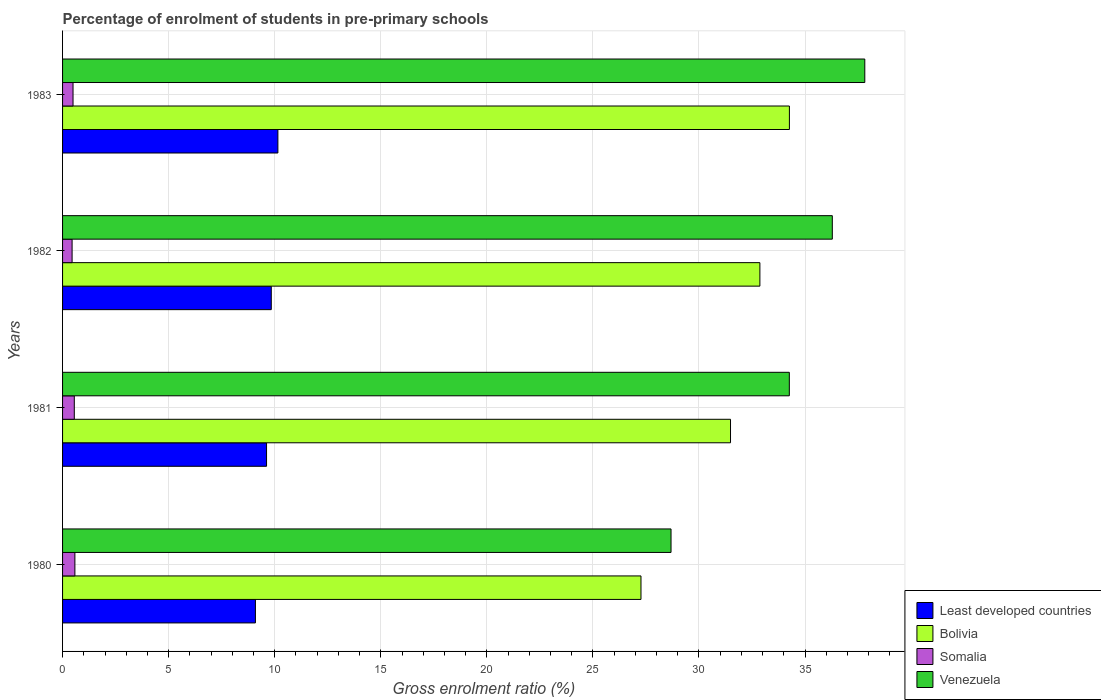How many different coloured bars are there?
Keep it short and to the point. 4. Are the number of bars on each tick of the Y-axis equal?
Give a very brief answer. Yes. How many bars are there on the 2nd tick from the top?
Your response must be concise. 4. How many bars are there on the 2nd tick from the bottom?
Provide a succinct answer. 4. What is the percentage of students enrolled in pre-primary schools in Venezuela in 1983?
Offer a terse response. 37.82. Across all years, what is the maximum percentage of students enrolled in pre-primary schools in Somalia?
Provide a succinct answer. 0.58. Across all years, what is the minimum percentage of students enrolled in pre-primary schools in Least developed countries?
Provide a succinct answer. 9.09. What is the total percentage of students enrolled in pre-primary schools in Bolivia in the graph?
Provide a short and direct response. 125.89. What is the difference between the percentage of students enrolled in pre-primary schools in Least developed countries in 1980 and that in 1981?
Keep it short and to the point. -0.52. What is the difference between the percentage of students enrolled in pre-primary schools in Least developed countries in 1981 and the percentage of students enrolled in pre-primary schools in Venezuela in 1982?
Offer a terse response. -26.67. What is the average percentage of students enrolled in pre-primary schools in Least developed countries per year?
Offer a very short reply. 9.67. In the year 1983, what is the difference between the percentage of students enrolled in pre-primary schools in Least developed countries and percentage of students enrolled in pre-primary schools in Bolivia?
Offer a terse response. -24.11. What is the ratio of the percentage of students enrolled in pre-primary schools in Bolivia in 1980 to that in 1983?
Offer a terse response. 0.8. Is the difference between the percentage of students enrolled in pre-primary schools in Least developed countries in 1980 and 1981 greater than the difference between the percentage of students enrolled in pre-primary schools in Bolivia in 1980 and 1981?
Keep it short and to the point. Yes. What is the difference between the highest and the second highest percentage of students enrolled in pre-primary schools in Least developed countries?
Provide a succinct answer. 0.31. What is the difference between the highest and the lowest percentage of students enrolled in pre-primary schools in Bolivia?
Your response must be concise. 7. Is it the case that in every year, the sum of the percentage of students enrolled in pre-primary schools in Somalia and percentage of students enrolled in pre-primary schools in Bolivia is greater than the sum of percentage of students enrolled in pre-primary schools in Venezuela and percentage of students enrolled in pre-primary schools in Least developed countries?
Provide a succinct answer. No. How many bars are there?
Give a very brief answer. 16. What is the difference between two consecutive major ticks on the X-axis?
Your answer should be compact. 5. Are the values on the major ticks of X-axis written in scientific E-notation?
Ensure brevity in your answer.  No. Does the graph contain any zero values?
Offer a terse response. No. Does the graph contain grids?
Your answer should be very brief. Yes. Where does the legend appear in the graph?
Provide a succinct answer. Bottom right. How are the legend labels stacked?
Keep it short and to the point. Vertical. What is the title of the graph?
Give a very brief answer. Percentage of enrolment of students in pre-primary schools. Does "Palau" appear as one of the legend labels in the graph?
Your answer should be compact. No. What is the label or title of the X-axis?
Offer a terse response. Gross enrolment ratio (%). What is the Gross enrolment ratio (%) in Least developed countries in 1980?
Offer a very short reply. 9.09. What is the Gross enrolment ratio (%) in Bolivia in 1980?
Offer a terse response. 27.27. What is the Gross enrolment ratio (%) of Somalia in 1980?
Your answer should be compact. 0.58. What is the Gross enrolment ratio (%) in Venezuela in 1980?
Keep it short and to the point. 28.68. What is the Gross enrolment ratio (%) of Least developed countries in 1981?
Your answer should be compact. 9.62. What is the Gross enrolment ratio (%) of Bolivia in 1981?
Your answer should be compact. 31.49. What is the Gross enrolment ratio (%) in Somalia in 1981?
Your answer should be compact. 0.55. What is the Gross enrolment ratio (%) of Venezuela in 1981?
Your answer should be compact. 34.26. What is the Gross enrolment ratio (%) of Least developed countries in 1982?
Offer a terse response. 9.84. What is the Gross enrolment ratio (%) in Bolivia in 1982?
Ensure brevity in your answer.  32.87. What is the Gross enrolment ratio (%) in Somalia in 1982?
Your answer should be compact. 0.45. What is the Gross enrolment ratio (%) in Venezuela in 1982?
Provide a succinct answer. 36.28. What is the Gross enrolment ratio (%) in Least developed countries in 1983?
Offer a very short reply. 10.15. What is the Gross enrolment ratio (%) in Bolivia in 1983?
Your answer should be very brief. 34.26. What is the Gross enrolment ratio (%) in Somalia in 1983?
Your answer should be very brief. 0.49. What is the Gross enrolment ratio (%) of Venezuela in 1983?
Your answer should be compact. 37.82. Across all years, what is the maximum Gross enrolment ratio (%) in Least developed countries?
Ensure brevity in your answer.  10.15. Across all years, what is the maximum Gross enrolment ratio (%) in Bolivia?
Ensure brevity in your answer.  34.26. Across all years, what is the maximum Gross enrolment ratio (%) of Somalia?
Your response must be concise. 0.58. Across all years, what is the maximum Gross enrolment ratio (%) in Venezuela?
Offer a terse response. 37.82. Across all years, what is the minimum Gross enrolment ratio (%) in Least developed countries?
Your answer should be very brief. 9.09. Across all years, what is the minimum Gross enrolment ratio (%) of Bolivia?
Provide a succinct answer. 27.27. Across all years, what is the minimum Gross enrolment ratio (%) in Somalia?
Provide a short and direct response. 0.45. Across all years, what is the minimum Gross enrolment ratio (%) in Venezuela?
Your response must be concise. 28.68. What is the total Gross enrolment ratio (%) of Least developed countries in the graph?
Offer a very short reply. 38.69. What is the total Gross enrolment ratio (%) of Bolivia in the graph?
Your answer should be compact. 125.89. What is the total Gross enrolment ratio (%) of Somalia in the graph?
Your answer should be compact. 2.08. What is the total Gross enrolment ratio (%) in Venezuela in the graph?
Your answer should be very brief. 137.04. What is the difference between the Gross enrolment ratio (%) in Least developed countries in 1980 and that in 1981?
Offer a very short reply. -0.52. What is the difference between the Gross enrolment ratio (%) of Bolivia in 1980 and that in 1981?
Make the answer very short. -4.22. What is the difference between the Gross enrolment ratio (%) in Somalia in 1980 and that in 1981?
Ensure brevity in your answer.  0.03. What is the difference between the Gross enrolment ratio (%) of Venezuela in 1980 and that in 1981?
Provide a short and direct response. -5.58. What is the difference between the Gross enrolment ratio (%) in Least developed countries in 1980 and that in 1982?
Offer a very short reply. -0.75. What is the difference between the Gross enrolment ratio (%) in Bolivia in 1980 and that in 1982?
Your answer should be very brief. -5.61. What is the difference between the Gross enrolment ratio (%) in Somalia in 1980 and that in 1982?
Provide a short and direct response. 0.13. What is the difference between the Gross enrolment ratio (%) of Venezuela in 1980 and that in 1982?
Offer a very short reply. -7.6. What is the difference between the Gross enrolment ratio (%) in Least developed countries in 1980 and that in 1983?
Keep it short and to the point. -1.06. What is the difference between the Gross enrolment ratio (%) of Bolivia in 1980 and that in 1983?
Keep it short and to the point. -7. What is the difference between the Gross enrolment ratio (%) in Somalia in 1980 and that in 1983?
Your answer should be compact. 0.09. What is the difference between the Gross enrolment ratio (%) of Venezuela in 1980 and that in 1983?
Provide a succinct answer. -9.13. What is the difference between the Gross enrolment ratio (%) of Least developed countries in 1981 and that in 1982?
Keep it short and to the point. -0.22. What is the difference between the Gross enrolment ratio (%) in Bolivia in 1981 and that in 1982?
Offer a terse response. -1.38. What is the difference between the Gross enrolment ratio (%) in Somalia in 1981 and that in 1982?
Keep it short and to the point. 0.1. What is the difference between the Gross enrolment ratio (%) of Venezuela in 1981 and that in 1982?
Provide a short and direct response. -2.03. What is the difference between the Gross enrolment ratio (%) in Least developed countries in 1981 and that in 1983?
Ensure brevity in your answer.  -0.53. What is the difference between the Gross enrolment ratio (%) in Bolivia in 1981 and that in 1983?
Provide a short and direct response. -2.78. What is the difference between the Gross enrolment ratio (%) in Somalia in 1981 and that in 1983?
Give a very brief answer. 0.06. What is the difference between the Gross enrolment ratio (%) of Venezuela in 1981 and that in 1983?
Your response must be concise. -3.56. What is the difference between the Gross enrolment ratio (%) of Least developed countries in 1982 and that in 1983?
Offer a very short reply. -0.31. What is the difference between the Gross enrolment ratio (%) of Bolivia in 1982 and that in 1983?
Make the answer very short. -1.39. What is the difference between the Gross enrolment ratio (%) in Somalia in 1982 and that in 1983?
Offer a terse response. -0.04. What is the difference between the Gross enrolment ratio (%) in Venezuela in 1982 and that in 1983?
Give a very brief answer. -1.53. What is the difference between the Gross enrolment ratio (%) of Least developed countries in 1980 and the Gross enrolment ratio (%) of Bolivia in 1981?
Provide a succinct answer. -22.4. What is the difference between the Gross enrolment ratio (%) of Least developed countries in 1980 and the Gross enrolment ratio (%) of Somalia in 1981?
Provide a succinct answer. 8.54. What is the difference between the Gross enrolment ratio (%) in Least developed countries in 1980 and the Gross enrolment ratio (%) in Venezuela in 1981?
Offer a terse response. -25.17. What is the difference between the Gross enrolment ratio (%) in Bolivia in 1980 and the Gross enrolment ratio (%) in Somalia in 1981?
Ensure brevity in your answer.  26.71. What is the difference between the Gross enrolment ratio (%) of Bolivia in 1980 and the Gross enrolment ratio (%) of Venezuela in 1981?
Give a very brief answer. -6.99. What is the difference between the Gross enrolment ratio (%) in Somalia in 1980 and the Gross enrolment ratio (%) in Venezuela in 1981?
Offer a terse response. -33.68. What is the difference between the Gross enrolment ratio (%) of Least developed countries in 1980 and the Gross enrolment ratio (%) of Bolivia in 1982?
Offer a terse response. -23.78. What is the difference between the Gross enrolment ratio (%) in Least developed countries in 1980 and the Gross enrolment ratio (%) in Somalia in 1982?
Your answer should be very brief. 8.64. What is the difference between the Gross enrolment ratio (%) of Least developed countries in 1980 and the Gross enrolment ratio (%) of Venezuela in 1982?
Your response must be concise. -27.19. What is the difference between the Gross enrolment ratio (%) of Bolivia in 1980 and the Gross enrolment ratio (%) of Somalia in 1982?
Your answer should be compact. 26.82. What is the difference between the Gross enrolment ratio (%) of Bolivia in 1980 and the Gross enrolment ratio (%) of Venezuela in 1982?
Your response must be concise. -9.02. What is the difference between the Gross enrolment ratio (%) of Somalia in 1980 and the Gross enrolment ratio (%) of Venezuela in 1982?
Ensure brevity in your answer.  -35.7. What is the difference between the Gross enrolment ratio (%) in Least developed countries in 1980 and the Gross enrolment ratio (%) in Bolivia in 1983?
Provide a short and direct response. -25.17. What is the difference between the Gross enrolment ratio (%) in Least developed countries in 1980 and the Gross enrolment ratio (%) in Somalia in 1983?
Your response must be concise. 8.6. What is the difference between the Gross enrolment ratio (%) in Least developed countries in 1980 and the Gross enrolment ratio (%) in Venezuela in 1983?
Your response must be concise. -28.73. What is the difference between the Gross enrolment ratio (%) of Bolivia in 1980 and the Gross enrolment ratio (%) of Somalia in 1983?
Your response must be concise. 26.77. What is the difference between the Gross enrolment ratio (%) of Bolivia in 1980 and the Gross enrolment ratio (%) of Venezuela in 1983?
Ensure brevity in your answer.  -10.55. What is the difference between the Gross enrolment ratio (%) in Somalia in 1980 and the Gross enrolment ratio (%) in Venezuela in 1983?
Make the answer very short. -37.23. What is the difference between the Gross enrolment ratio (%) in Least developed countries in 1981 and the Gross enrolment ratio (%) in Bolivia in 1982?
Offer a terse response. -23.26. What is the difference between the Gross enrolment ratio (%) in Least developed countries in 1981 and the Gross enrolment ratio (%) in Somalia in 1982?
Provide a succinct answer. 9.17. What is the difference between the Gross enrolment ratio (%) of Least developed countries in 1981 and the Gross enrolment ratio (%) of Venezuela in 1982?
Your answer should be compact. -26.67. What is the difference between the Gross enrolment ratio (%) in Bolivia in 1981 and the Gross enrolment ratio (%) in Somalia in 1982?
Offer a very short reply. 31.04. What is the difference between the Gross enrolment ratio (%) in Bolivia in 1981 and the Gross enrolment ratio (%) in Venezuela in 1982?
Give a very brief answer. -4.8. What is the difference between the Gross enrolment ratio (%) of Somalia in 1981 and the Gross enrolment ratio (%) of Venezuela in 1982?
Make the answer very short. -35.73. What is the difference between the Gross enrolment ratio (%) in Least developed countries in 1981 and the Gross enrolment ratio (%) in Bolivia in 1983?
Keep it short and to the point. -24.65. What is the difference between the Gross enrolment ratio (%) in Least developed countries in 1981 and the Gross enrolment ratio (%) in Somalia in 1983?
Give a very brief answer. 9.12. What is the difference between the Gross enrolment ratio (%) in Least developed countries in 1981 and the Gross enrolment ratio (%) in Venezuela in 1983?
Ensure brevity in your answer.  -28.2. What is the difference between the Gross enrolment ratio (%) in Bolivia in 1981 and the Gross enrolment ratio (%) in Somalia in 1983?
Keep it short and to the point. 30.99. What is the difference between the Gross enrolment ratio (%) of Bolivia in 1981 and the Gross enrolment ratio (%) of Venezuela in 1983?
Offer a very short reply. -6.33. What is the difference between the Gross enrolment ratio (%) of Somalia in 1981 and the Gross enrolment ratio (%) of Venezuela in 1983?
Keep it short and to the point. -37.26. What is the difference between the Gross enrolment ratio (%) of Least developed countries in 1982 and the Gross enrolment ratio (%) of Bolivia in 1983?
Give a very brief answer. -24.42. What is the difference between the Gross enrolment ratio (%) in Least developed countries in 1982 and the Gross enrolment ratio (%) in Somalia in 1983?
Your response must be concise. 9.35. What is the difference between the Gross enrolment ratio (%) of Least developed countries in 1982 and the Gross enrolment ratio (%) of Venezuela in 1983?
Keep it short and to the point. -27.98. What is the difference between the Gross enrolment ratio (%) of Bolivia in 1982 and the Gross enrolment ratio (%) of Somalia in 1983?
Offer a very short reply. 32.38. What is the difference between the Gross enrolment ratio (%) of Bolivia in 1982 and the Gross enrolment ratio (%) of Venezuela in 1983?
Ensure brevity in your answer.  -4.95. What is the difference between the Gross enrolment ratio (%) in Somalia in 1982 and the Gross enrolment ratio (%) in Venezuela in 1983?
Your response must be concise. -37.37. What is the average Gross enrolment ratio (%) of Least developed countries per year?
Provide a short and direct response. 9.67. What is the average Gross enrolment ratio (%) of Bolivia per year?
Ensure brevity in your answer.  31.47. What is the average Gross enrolment ratio (%) in Somalia per year?
Provide a short and direct response. 0.52. What is the average Gross enrolment ratio (%) of Venezuela per year?
Your answer should be very brief. 34.26. In the year 1980, what is the difference between the Gross enrolment ratio (%) in Least developed countries and Gross enrolment ratio (%) in Bolivia?
Your answer should be very brief. -18.18. In the year 1980, what is the difference between the Gross enrolment ratio (%) of Least developed countries and Gross enrolment ratio (%) of Somalia?
Make the answer very short. 8.51. In the year 1980, what is the difference between the Gross enrolment ratio (%) of Least developed countries and Gross enrolment ratio (%) of Venezuela?
Give a very brief answer. -19.59. In the year 1980, what is the difference between the Gross enrolment ratio (%) in Bolivia and Gross enrolment ratio (%) in Somalia?
Offer a very short reply. 26.68. In the year 1980, what is the difference between the Gross enrolment ratio (%) in Bolivia and Gross enrolment ratio (%) in Venezuela?
Your answer should be compact. -1.42. In the year 1980, what is the difference between the Gross enrolment ratio (%) in Somalia and Gross enrolment ratio (%) in Venezuela?
Give a very brief answer. -28.1. In the year 1981, what is the difference between the Gross enrolment ratio (%) in Least developed countries and Gross enrolment ratio (%) in Bolivia?
Your answer should be very brief. -21.87. In the year 1981, what is the difference between the Gross enrolment ratio (%) of Least developed countries and Gross enrolment ratio (%) of Somalia?
Make the answer very short. 9.06. In the year 1981, what is the difference between the Gross enrolment ratio (%) in Least developed countries and Gross enrolment ratio (%) in Venezuela?
Ensure brevity in your answer.  -24.64. In the year 1981, what is the difference between the Gross enrolment ratio (%) in Bolivia and Gross enrolment ratio (%) in Somalia?
Your answer should be very brief. 30.93. In the year 1981, what is the difference between the Gross enrolment ratio (%) of Bolivia and Gross enrolment ratio (%) of Venezuela?
Ensure brevity in your answer.  -2.77. In the year 1981, what is the difference between the Gross enrolment ratio (%) in Somalia and Gross enrolment ratio (%) in Venezuela?
Your answer should be very brief. -33.71. In the year 1982, what is the difference between the Gross enrolment ratio (%) of Least developed countries and Gross enrolment ratio (%) of Bolivia?
Provide a short and direct response. -23.03. In the year 1982, what is the difference between the Gross enrolment ratio (%) in Least developed countries and Gross enrolment ratio (%) in Somalia?
Your response must be concise. 9.39. In the year 1982, what is the difference between the Gross enrolment ratio (%) of Least developed countries and Gross enrolment ratio (%) of Venezuela?
Provide a succinct answer. -26.45. In the year 1982, what is the difference between the Gross enrolment ratio (%) of Bolivia and Gross enrolment ratio (%) of Somalia?
Give a very brief answer. 32.42. In the year 1982, what is the difference between the Gross enrolment ratio (%) of Bolivia and Gross enrolment ratio (%) of Venezuela?
Your response must be concise. -3.41. In the year 1982, what is the difference between the Gross enrolment ratio (%) of Somalia and Gross enrolment ratio (%) of Venezuela?
Provide a succinct answer. -35.83. In the year 1983, what is the difference between the Gross enrolment ratio (%) in Least developed countries and Gross enrolment ratio (%) in Bolivia?
Keep it short and to the point. -24.11. In the year 1983, what is the difference between the Gross enrolment ratio (%) in Least developed countries and Gross enrolment ratio (%) in Somalia?
Give a very brief answer. 9.66. In the year 1983, what is the difference between the Gross enrolment ratio (%) of Least developed countries and Gross enrolment ratio (%) of Venezuela?
Offer a very short reply. -27.67. In the year 1983, what is the difference between the Gross enrolment ratio (%) of Bolivia and Gross enrolment ratio (%) of Somalia?
Offer a very short reply. 33.77. In the year 1983, what is the difference between the Gross enrolment ratio (%) of Bolivia and Gross enrolment ratio (%) of Venezuela?
Your response must be concise. -3.55. In the year 1983, what is the difference between the Gross enrolment ratio (%) in Somalia and Gross enrolment ratio (%) in Venezuela?
Your answer should be compact. -37.32. What is the ratio of the Gross enrolment ratio (%) of Least developed countries in 1980 to that in 1981?
Your response must be concise. 0.95. What is the ratio of the Gross enrolment ratio (%) in Bolivia in 1980 to that in 1981?
Give a very brief answer. 0.87. What is the ratio of the Gross enrolment ratio (%) in Somalia in 1980 to that in 1981?
Give a very brief answer. 1.05. What is the ratio of the Gross enrolment ratio (%) in Venezuela in 1980 to that in 1981?
Keep it short and to the point. 0.84. What is the ratio of the Gross enrolment ratio (%) in Least developed countries in 1980 to that in 1982?
Ensure brevity in your answer.  0.92. What is the ratio of the Gross enrolment ratio (%) in Bolivia in 1980 to that in 1982?
Offer a very short reply. 0.83. What is the ratio of the Gross enrolment ratio (%) in Somalia in 1980 to that in 1982?
Give a very brief answer. 1.29. What is the ratio of the Gross enrolment ratio (%) of Venezuela in 1980 to that in 1982?
Offer a very short reply. 0.79. What is the ratio of the Gross enrolment ratio (%) of Least developed countries in 1980 to that in 1983?
Your answer should be compact. 0.9. What is the ratio of the Gross enrolment ratio (%) in Bolivia in 1980 to that in 1983?
Your response must be concise. 0.8. What is the ratio of the Gross enrolment ratio (%) of Somalia in 1980 to that in 1983?
Offer a very short reply. 1.18. What is the ratio of the Gross enrolment ratio (%) of Venezuela in 1980 to that in 1983?
Keep it short and to the point. 0.76. What is the ratio of the Gross enrolment ratio (%) in Least developed countries in 1981 to that in 1982?
Your response must be concise. 0.98. What is the ratio of the Gross enrolment ratio (%) in Bolivia in 1981 to that in 1982?
Your answer should be very brief. 0.96. What is the ratio of the Gross enrolment ratio (%) in Somalia in 1981 to that in 1982?
Ensure brevity in your answer.  1.23. What is the ratio of the Gross enrolment ratio (%) of Venezuela in 1981 to that in 1982?
Give a very brief answer. 0.94. What is the ratio of the Gross enrolment ratio (%) of Least developed countries in 1981 to that in 1983?
Keep it short and to the point. 0.95. What is the ratio of the Gross enrolment ratio (%) in Bolivia in 1981 to that in 1983?
Ensure brevity in your answer.  0.92. What is the ratio of the Gross enrolment ratio (%) in Somalia in 1981 to that in 1983?
Provide a short and direct response. 1.12. What is the ratio of the Gross enrolment ratio (%) of Venezuela in 1981 to that in 1983?
Make the answer very short. 0.91. What is the ratio of the Gross enrolment ratio (%) in Least developed countries in 1982 to that in 1983?
Offer a very short reply. 0.97. What is the ratio of the Gross enrolment ratio (%) in Bolivia in 1982 to that in 1983?
Offer a terse response. 0.96. What is the ratio of the Gross enrolment ratio (%) of Somalia in 1982 to that in 1983?
Keep it short and to the point. 0.91. What is the ratio of the Gross enrolment ratio (%) in Venezuela in 1982 to that in 1983?
Your answer should be compact. 0.96. What is the difference between the highest and the second highest Gross enrolment ratio (%) of Least developed countries?
Your answer should be very brief. 0.31. What is the difference between the highest and the second highest Gross enrolment ratio (%) of Bolivia?
Offer a terse response. 1.39. What is the difference between the highest and the second highest Gross enrolment ratio (%) in Somalia?
Ensure brevity in your answer.  0.03. What is the difference between the highest and the second highest Gross enrolment ratio (%) in Venezuela?
Your answer should be very brief. 1.53. What is the difference between the highest and the lowest Gross enrolment ratio (%) in Least developed countries?
Provide a short and direct response. 1.06. What is the difference between the highest and the lowest Gross enrolment ratio (%) of Bolivia?
Provide a succinct answer. 7. What is the difference between the highest and the lowest Gross enrolment ratio (%) in Somalia?
Provide a succinct answer. 0.13. What is the difference between the highest and the lowest Gross enrolment ratio (%) in Venezuela?
Provide a succinct answer. 9.13. 